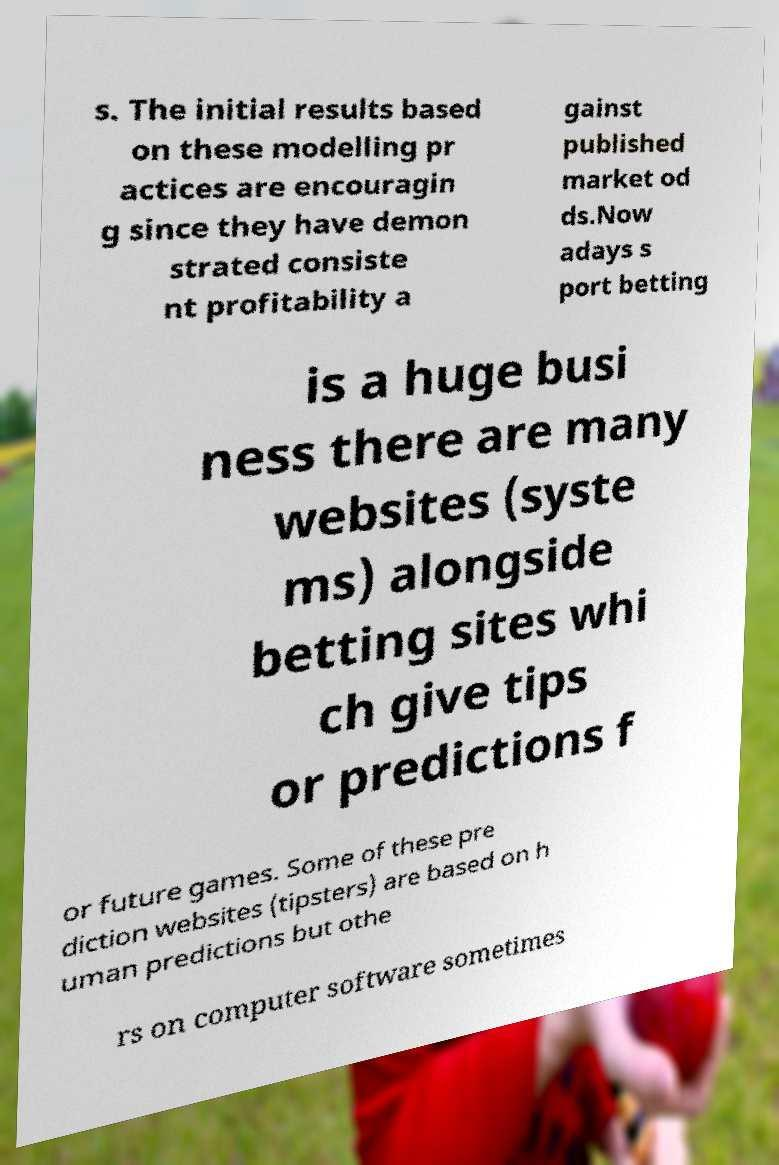Could you assist in decoding the text presented in this image and type it out clearly? s. The initial results based on these modelling pr actices are encouragin g since they have demon strated consiste nt profitability a gainst published market od ds.Now adays s port betting is a huge busi ness there are many websites (syste ms) alongside betting sites whi ch give tips or predictions f or future games. Some of these pre diction websites (tipsters) are based on h uman predictions but othe rs on computer software sometimes 